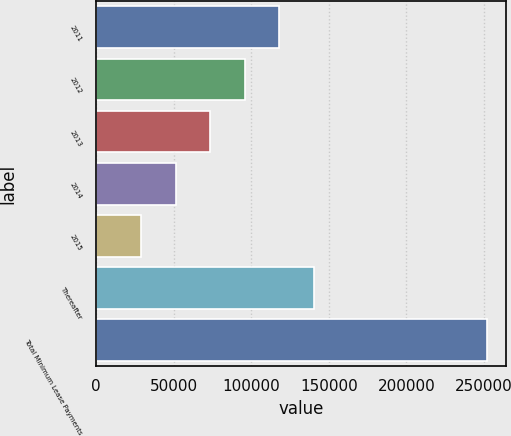Convert chart to OTSL. <chart><loc_0><loc_0><loc_500><loc_500><bar_chart><fcel>2011<fcel>2012<fcel>2013<fcel>2014<fcel>2015<fcel>Thereafter<fcel>Total Minimum Lease Payments<nl><fcel>118162<fcel>95916.8<fcel>73671.2<fcel>51425.6<fcel>29180<fcel>140408<fcel>251636<nl></chart> 